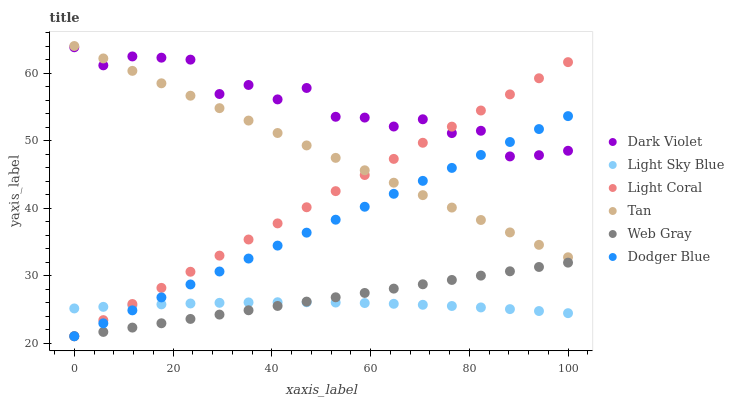Does Light Sky Blue have the minimum area under the curve?
Answer yes or no. Yes. Does Dark Violet have the maximum area under the curve?
Answer yes or no. Yes. Does Light Coral have the minimum area under the curve?
Answer yes or no. No. Does Light Coral have the maximum area under the curve?
Answer yes or no. No. Is Web Gray the smoothest?
Answer yes or no. Yes. Is Dark Violet the roughest?
Answer yes or no. Yes. Is Light Coral the smoothest?
Answer yes or no. No. Is Light Coral the roughest?
Answer yes or no. No. Does Web Gray have the lowest value?
Answer yes or no. Yes. Does Dark Violet have the lowest value?
Answer yes or no. No. Does Tan have the highest value?
Answer yes or no. Yes. Does Dark Violet have the highest value?
Answer yes or no. No. Is Web Gray less than Dark Violet?
Answer yes or no. Yes. Is Tan greater than Light Sky Blue?
Answer yes or no. Yes. Does Light Coral intersect Dodger Blue?
Answer yes or no. Yes. Is Light Coral less than Dodger Blue?
Answer yes or no. No. Is Light Coral greater than Dodger Blue?
Answer yes or no. No. Does Web Gray intersect Dark Violet?
Answer yes or no. No. 